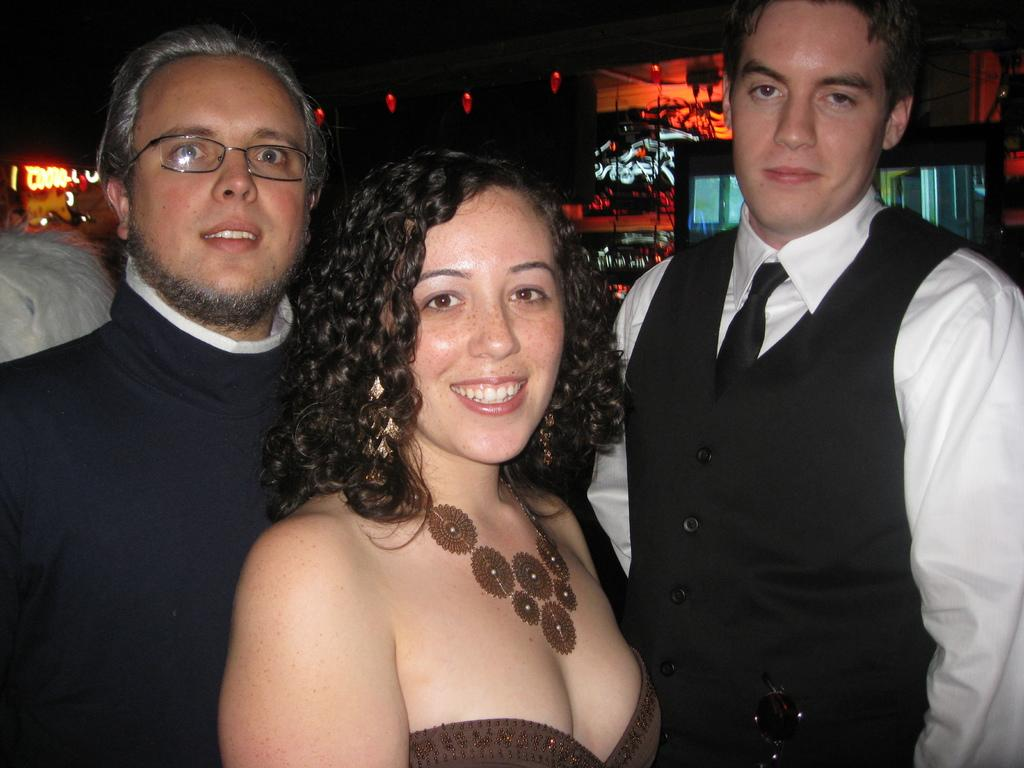How many people are in the image? There are three people in the image: two men and one woman. What are the people in the image doing? The people are standing and smiling. What can be seen in the background of the image? There are buildings with glass doors and lighting visible in the background. What type of pickle is being used as a prop in the image? There is no pickle present in the image. What type of wood is visible in the image? There is no wood visible in the image. 